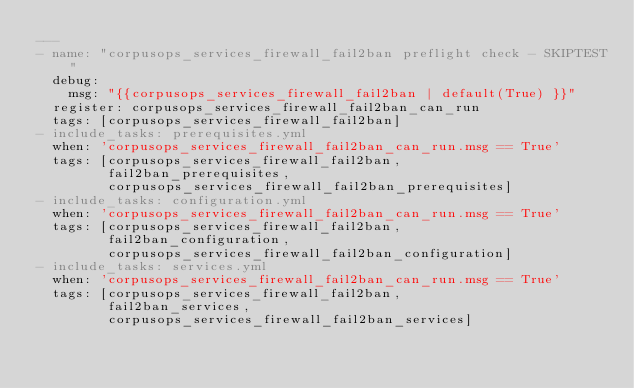<code> <loc_0><loc_0><loc_500><loc_500><_YAML_>---
- name: "corpusops_services_firewall_fail2ban preflight check - SKIPTEST"
  debug:
    msg: "{{corpusops_services_firewall_fail2ban | default(True) }}"
  register: corpusops_services_firewall_fail2ban_can_run
  tags: [corpusops_services_firewall_fail2ban]
- include_tasks: prerequisites.yml
  when: 'corpusops_services_firewall_fail2ban_can_run.msg == True'
  tags: [corpusops_services_firewall_fail2ban,
         fail2ban_prerequisites,
         corpusops_services_firewall_fail2ban_prerequisites]
- include_tasks: configuration.yml
  when: 'corpusops_services_firewall_fail2ban_can_run.msg == True'
  tags: [corpusops_services_firewall_fail2ban,
         fail2ban_configuration,
         corpusops_services_firewall_fail2ban_configuration]
- include_tasks: services.yml
  when: 'corpusops_services_firewall_fail2ban_can_run.msg == True'
  tags: [corpusops_services_firewall_fail2ban,
         fail2ban_services,
         corpusops_services_firewall_fail2ban_services]
</code> 